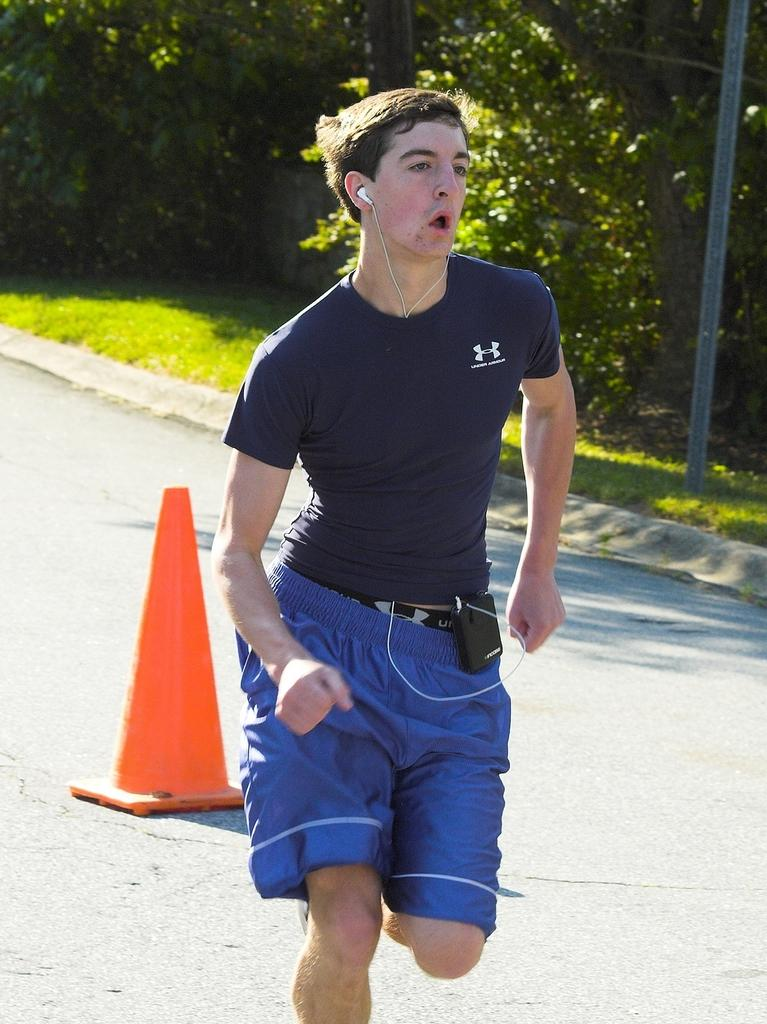What is the main subject of the image? There is a man in the image. What is the man doing in the image? The man is running. What color is the T-shirt the man is wearing? The man is wearing a blue T-shirt. What can be seen in the background of the image? There is a grass path, plants, and a pole in the background of the image. What type of advertisement can be seen on the pole in the image? There is no advertisement present on the pole in the image. What kind of trouble is the man experiencing while running in the image? There is no indication of trouble in the image; the man is simply running. 